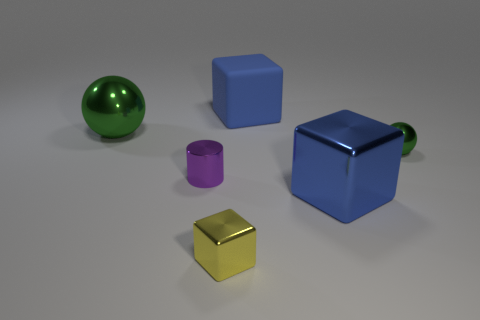Does the small metal ball have the same color as the large ball?
Offer a terse response. Yes. What color is the large thing that is both behind the small cylinder and on the right side of the small purple metallic cylinder?
Provide a short and direct response. Blue. Does the green sphere right of the yellow block have the same size as the large ball?
Your response must be concise. No. Is there any other thing that has the same shape as the purple object?
Offer a terse response. No. Is the material of the purple cylinder the same as the large blue thing that is behind the tiny purple thing?
Offer a terse response. No. How many purple objects are tiny metallic cylinders or big things?
Provide a succinct answer. 1. Are any red matte balls visible?
Your answer should be very brief. No. There is a green ball that is on the left side of the object behind the large ball; is there a tiny yellow metallic cube in front of it?
Make the answer very short. Yes. Does the big blue shiny object have the same shape as the small metal thing that is in front of the small shiny cylinder?
Provide a short and direct response. Yes. What color is the metallic sphere behind the metal sphere right of the large green metallic object behind the small cylinder?
Your answer should be compact. Green. 